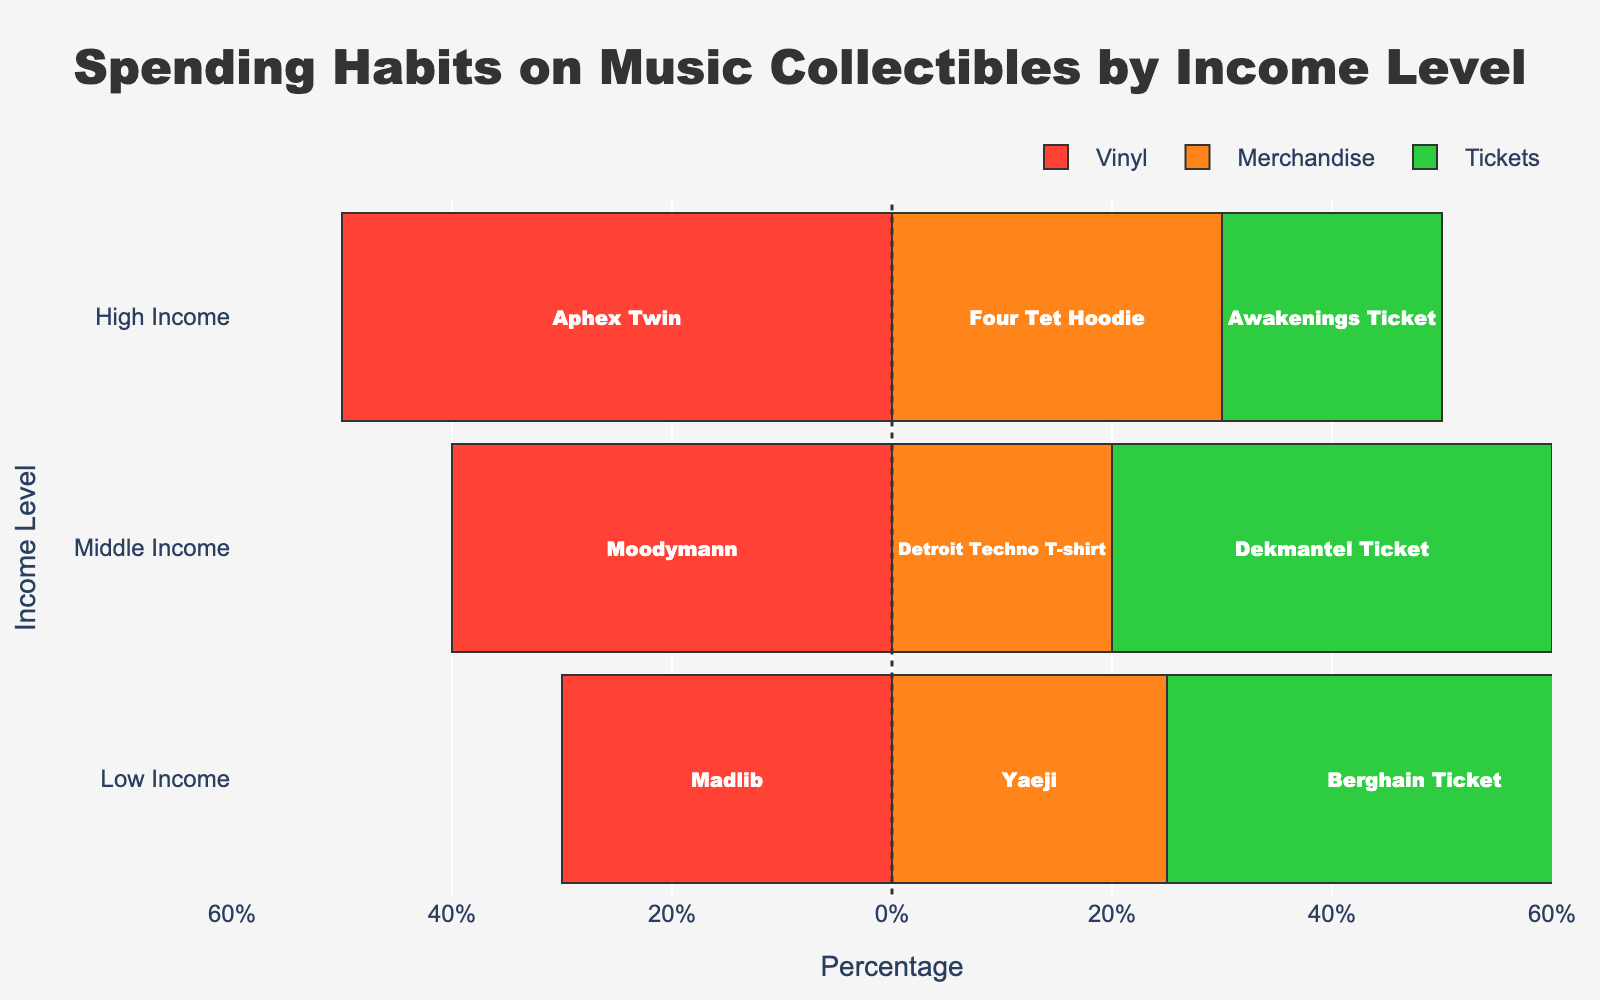Which income level spends the highest percentage on vinyl? By visually examining the chart, the bar representing "Vinyl" for "High Income" extends the farthest to the left.
Answer: High Income Which category has the highest percentage for low income? The chart shows that the "Tickets" bar for "Low Income" is the longest among the categories for this income group.
Answer: Tickets What is the total spending percentage on vinyl for low and middle income combined? Combine the "Vinyl" percentages for "Low Income" (30%) and "Middle Income" (40%), resulting in a total of 70%.
Answer: 70% How do the spending percentages on merchandise compare between middle and high income levels? By comparing the lengths of the "Merchandise" bars, "High Income" (30%) is longer than "Middle Income" (20%).
Answer: High Income > Middle Income If you add up the percentages of tickets for all income levels, what is the total? Sum the "Tickets" percentages for "Low Income" (45%), "Middle Income" (40%), and "High Income" (20%), resulting in a total of 105%.
Answer: 105% Which income level has the smallest percentage spent on tickets? The smallest "Tickets" bar is for "High Income" at 20%.
Answer: High Income Does any income level spend an equal percentage on different categories? By examining the lengths of the bars, "Middle Income" spends an equal percentage (40%) on both "Vinyl" and "Tickets".
Answer: Middle Income Which category is the least prioritized by low income individuals? The shortest bar for "Low Income" is "Merchandise" at 25%.
Answer: Merchandise Is the percentage spent on vinyl by high income individuals greater than the combined spending on tickets by middle and high income levels? Compare "Vinyl" for "High Income" (50%) with the sum of "Tickets" for "Middle Income" (40%) and "High Income" (20%), which totals 60%. Since 50% is less, the answer is no.
Answer: No 